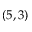<formula> <loc_0><loc_0><loc_500><loc_500>( 5 , 3 )</formula> 